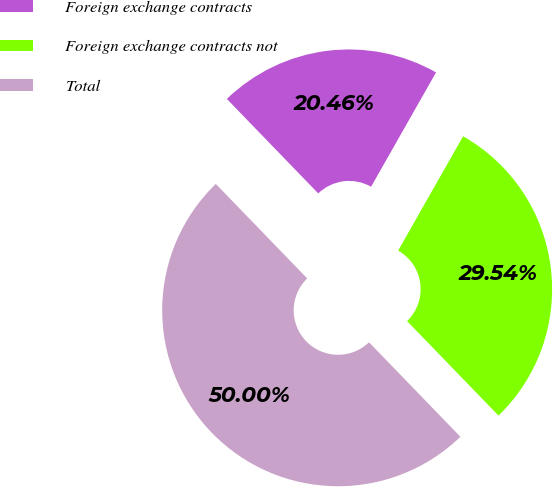Convert chart. <chart><loc_0><loc_0><loc_500><loc_500><pie_chart><fcel>Foreign exchange contracts<fcel>Foreign exchange contracts not<fcel>Total<nl><fcel>20.46%<fcel>29.54%<fcel>50.0%<nl></chart> 